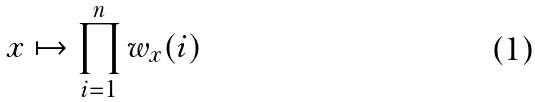Convert formula to latex. <formula><loc_0><loc_0><loc_500><loc_500>x \mapsto \prod _ { i = 1 } ^ { n } w _ { x } ( i )</formula> 